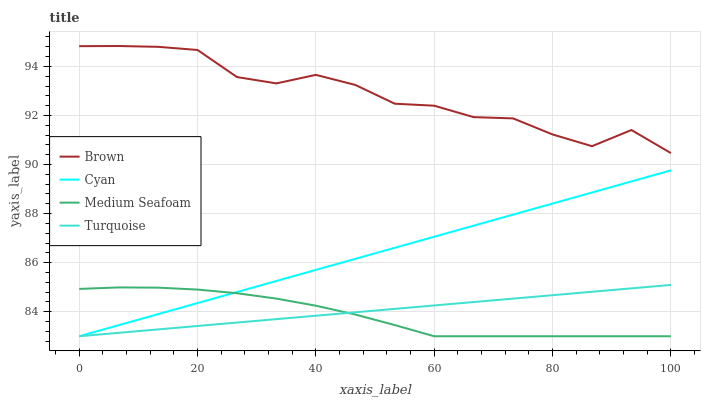Does Medium Seafoam have the minimum area under the curve?
Answer yes or no. Yes. Does Brown have the maximum area under the curve?
Answer yes or no. Yes. Does Turquoise have the minimum area under the curve?
Answer yes or no. No. Does Turquoise have the maximum area under the curve?
Answer yes or no. No. Is Turquoise the smoothest?
Answer yes or no. Yes. Is Brown the roughest?
Answer yes or no. Yes. Is Medium Seafoam the smoothest?
Answer yes or no. No. Is Medium Seafoam the roughest?
Answer yes or no. No. Does Brown have the highest value?
Answer yes or no. Yes. Does Turquoise have the highest value?
Answer yes or no. No. Is Medium Seafoam less than Brown?
Answer yes or no. Yes. Is Brown greater than Medium Seafoam?
Answer yes or no. Yes. Does Turquoise intersect Medium Seafoam?
Answer yes or no. Yes. Is Turquoise less than Medium Seafoam?
Answer yes or no. No. Is Turquoise greater than Medium Seafoam?
Answer yes or no. No. Does Medium Seafoam intersect Brown?
Answer yes or no. No. 